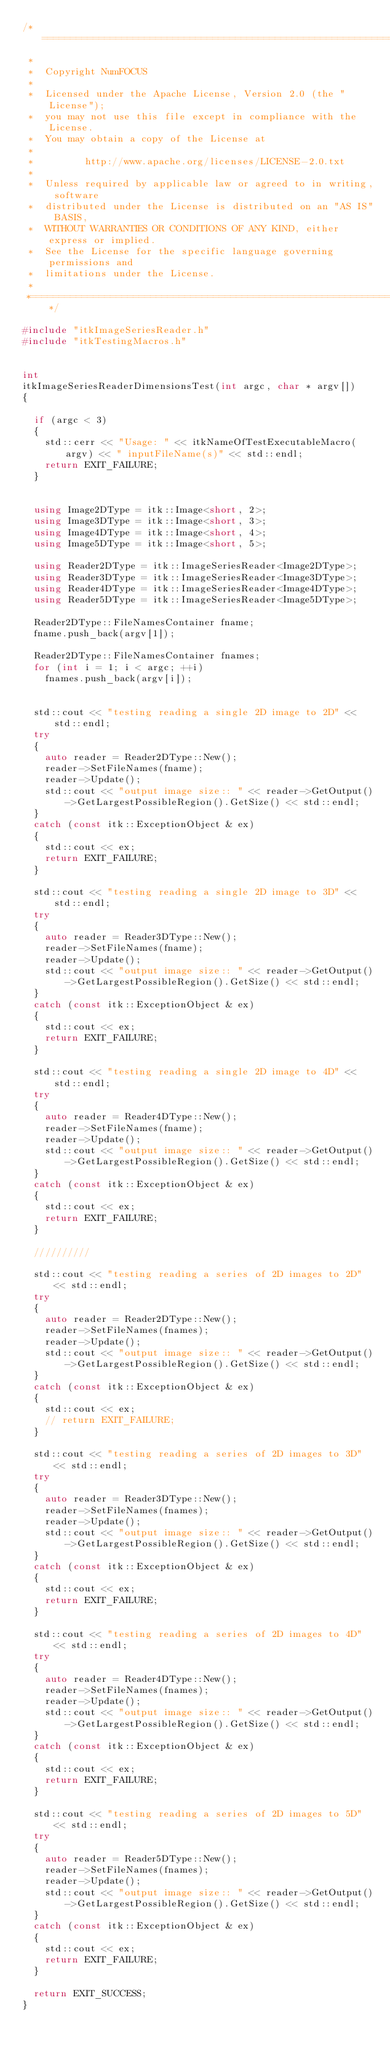<code> <loc_0><loc_0><loc_500><loc_500><_C++_>/*=========================================================================
 *
 *  Copyright NumFOCUS
 *
 *  Licensed under the Apache License, Version 2.0 (the "License");
 *  you may not use this file except in compliance with the License.
 *  You may obtain a copy of the License at
 *
 *         http://www.apache.org/licenses/LICENSE-2.0.txt
 *
 *  Unless required by applicable law or agreed to in writing, software
 *  distributed under the License is distributed on an "AS IS" BASIS,
 *  WITHOUT WARRANTIES OR CONDITIONS OF ANY KIND, either express or implied.
 *  See the License for the specific language governing permissions and
 *  limitations under the License.
 *
 *=========================================================================*/

#include "itkImageSeriesReader.h"
#include "itkTestingMacros.h"


int
itkImageSeriesReaderDimensionsTest(int argc, char * argv[])
{

  if (argc < 3)
  {
    std::cerr << "Usage: " << itkNameOfTestExecutableMacro(argv) << " inputFileName(s)" << std::endl;
    return EXIT_FAILURE;
  }


  using Image2DType = itk::Image<short, 2>;
  using Image3DType = itk::Image<short, 3>;
  using Image4DType = itk::Image<short, 4>;
  using Image5DType = itk::Image<short, 5>;

  using Reader2DType = itk::ImageSeriesReader<Image2DType>;
  using Reader3DType = itk::ImageSeriesReader<Image3DType>;
  using Reader4DType = itk::ImageSeriesReader<Image4DType>;
  using Reader5DType = itk::ImageSeriesReader<Image5DType>;

  Reader2DType::FileNamesContainer fname;
  fname.push_back(argv[1]);

  Reader2DType::FileNamesContainer fnames;
  for (int i = 1; i < argc; ++i)
    fnames.push_back(argv[i]);


  std::cout << "testing reading a single 2D image to 2D" << std::endl;
  try
  {
    auto reader = Reader2DType::New();
    reader->SetFileNames(fname);
    reader->Update();
    std::cout << "output image size:: " << reader->GetOutput()->GetLargestPossibleRegion().GetSize() << std::endl;
  }
  catch (const itk::ExceptionObject & ex)
  {
    std::cout << ex;
    return EXIT_FAILURE;
  }

  std::cout << "testing reading a single 2D image to 3D" << std::endl;
  try
  {
    auto reader = Reader3DType::New();
    reader->SetFileNames(fname);
    reader->Update();
    std::cout << "output image size:: " << reader->GetOutput()->GetLargestPossibleRegion().GetSize() << std::endl;
  }
  catch (const itk::ExceptionObject & ex)
  {
    std::cout << ex;
    return EXIT_FAILURE;
  }

  std::cout << "testing reading a single 2D image to 4D" << std::endl;
  try
  {
    auto reader = Reader4DType::New();
    reader->SetFileNames(fname);
    reader->Update();
    std::cout << "output image size:: " << reader->GetOutput()->GetLargestPossibleRegion().GetSize() << std::endl;
  }
  catch (const itk::ExceptionObject & ex)
  {
    std::cout << ex;
    return EXIT_FAILURE;
  }

  //////////

  std::cout << "testing reading a series of 2D images to 2D" << std::endl;
  try
  {
    auto reader = Reader2DType::New();
    reader->SetFileNames(fnames);
    reader->Update();
    std::cout << "output image size:: " << reader->GetOutput()->GetLargestPossibleRegion().GetSize() << std::endl;
  }
  catch (const itk::ExceptionObject & ex)
  {
    std::cout << ex;
    // return EXIT_FAILURE;
  }

  std::cout << "testing reading a series of 2D images to 3D" << std::endl;
  try
  {
    auto reader = Reader3DType::New();
    reader->SetFileNames(fnames);
    reader->Update();
    std::cout << "output image size:: " << reader->GetOutput()->GetLargestPossibleRegion().GetSize() << std::endl;
  }
  catch (const itk::ExceptionObject & ex)
  {
    std::cout << ex;
    return EXIT_FAILURE;
  }

  std::cout << "testing reading a series of 2D images to 4D" << std::endl;
  try
  {
    auto reader = Reader4DType::New();
    reader->SetFileNames(fnames);
    reader->Update();
    std::cout << "output image size:: " << reader->GetOutput()->GetLargestPossibleRegion().GetSize() << std::endl;
  }
  catch (const itk::ExceptionObject & ex)
  {
    std::cout << ex;
    return EXIT_FAILURE;
  }

  std::cout << "testing reading a series of 2D images to 5D" << std::endl;
  try
  {
    auto reader = Reader5DType::New();
    reader->SetFileNames(fnames);
    reader->Update();
    std::cout << "output image size:: " << reader->GetOutput()->GetLargestPossibleRegion().GetSize() << std::endl;
  }
  catch (const itk::ExceptionObject & ex)
  {
    std::cout << ex;
    return EXIT_FAILURE;
  }

  return EXIT_SUCCESS;
}
</code> 